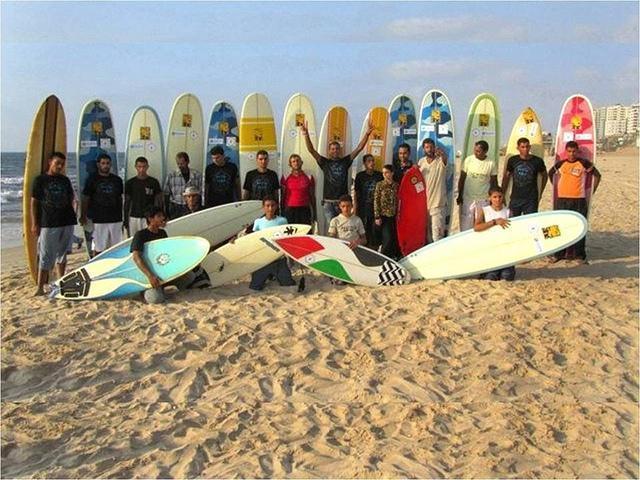How many surfboards on laying on the sand?
Give a very brief answer. 5. How many people are in the photo?
Give a very brief answer. 8. How many surfboards are there?
Give a very brief answer. 11. 